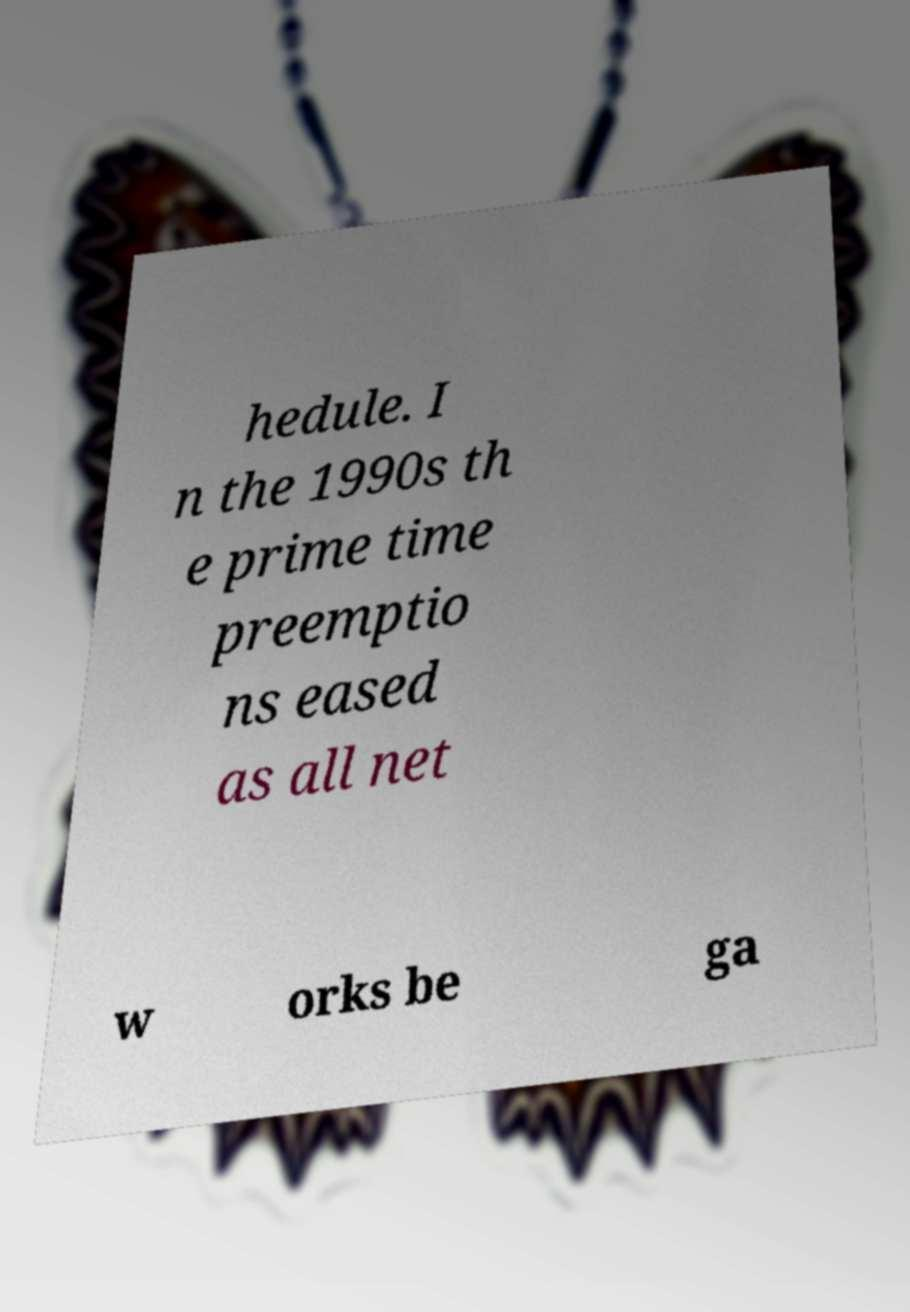Please read and relay the text visible in this image. What does it say? hedule. I n the 1990s th e prime time preemptio ns eased as all net w orks be ga 